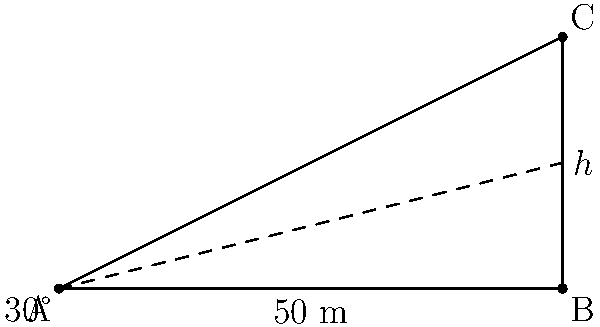A new storage facility for PPE supplies is being constructed. From a point A on the ground, the angle of elevation to the top of the facility (point C) is 30°. If the distance from point A to the base of the facility (point B) is 50 meters, what is the height $h$ of the storage facility? To find the height of the storage facility, we can use the tangent ratio in the right triangle ABC:

1) In a right triangle, $\tan(\theta) = \frac{\text{opposite}}{\text{adjacent}}$

2) Here, $\theta = 30°$, the adjacent side (AB) is 50 m, and we need to find the opposite side (BC), which is the height $h$.

3) Using the tangent ratio:
   $\tan(30°) = \frac{h}{50}$

4) We know that $\tan(30°) = \frac{1}{\sqrt{3}}$, so:
   $\frac{1}{\sqrt{3}} = \frac{h}{50}$

5) Cross multiply:
   $h = 50 \cdot \frac{1}{\sqrt{3}}$

6) Simplify:
   $h = \frac{50}{\sqrt{3}} = \frac{50\sqrt{3}}{3} \approx 28.87$ meters

Therefore, the height of the storage facility is approximately 28.87 meters.
Answer: $\frac{50\sqrt{3}}{3}$ m 